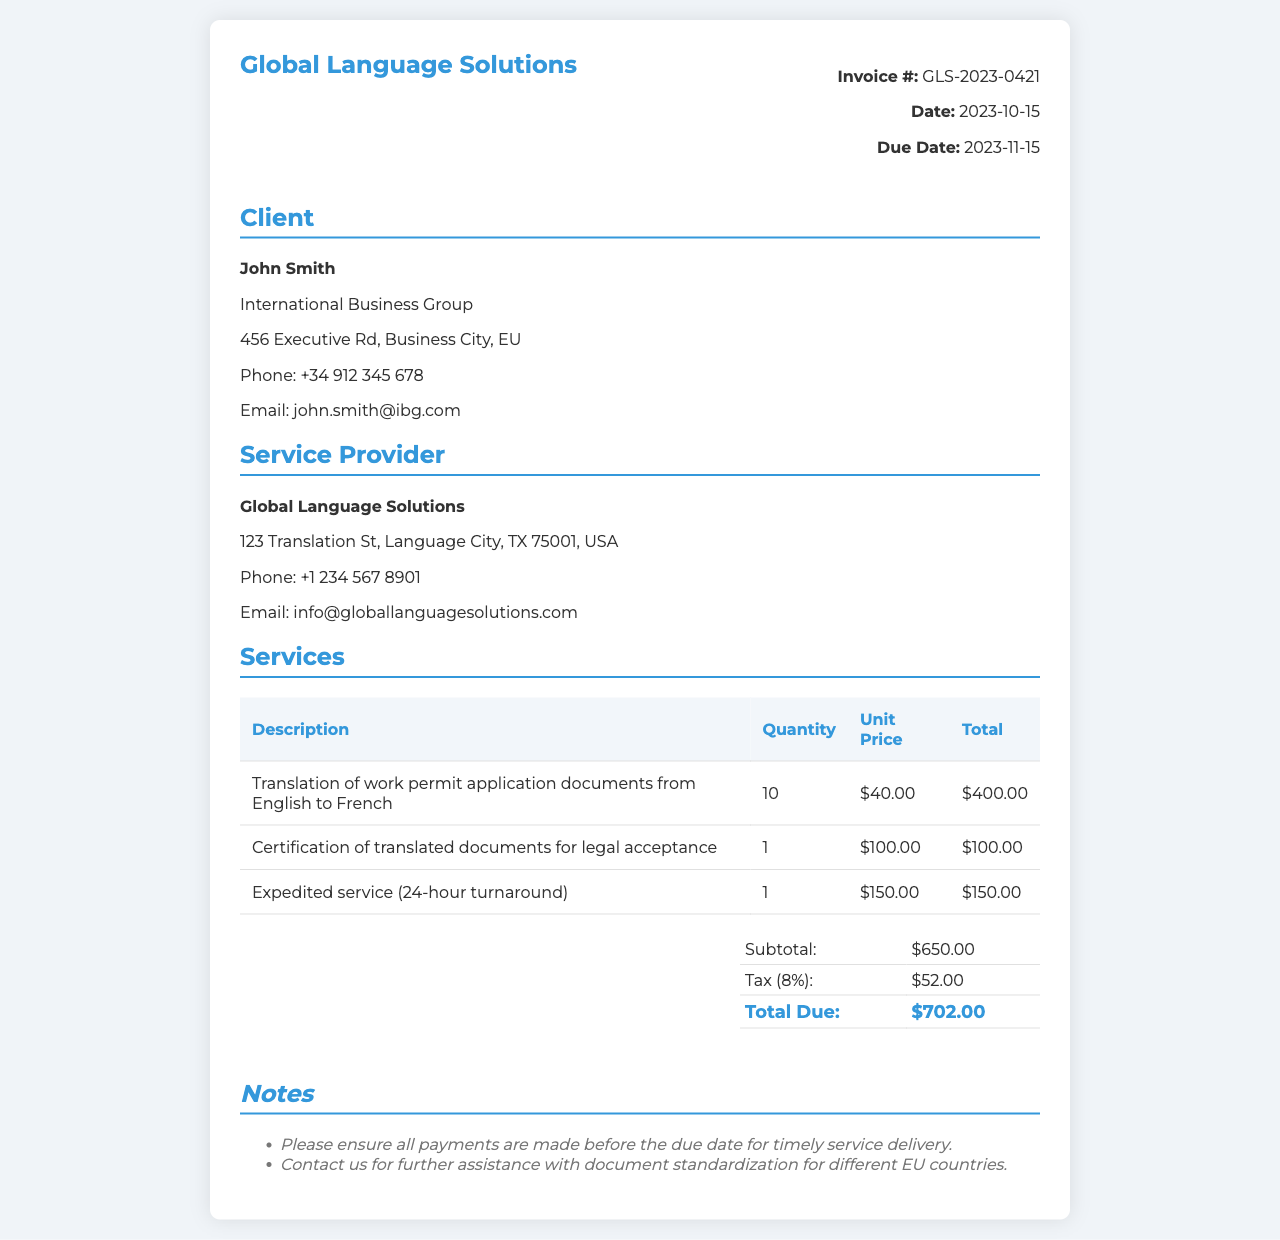What is the invoice number? The invoice number is specified in the document, which is important for tracking and reference purposes.
Answer: GLS-2023-0421 What is the date of the invoice? The date of the invoice indicates when the services were rendered and when payment is due.
Answer: 2023-10-15 Who is the client? The client section provides the name of the individual or organization receiving the services for identification.
Answer: John Smith What is the total due amount? The total due amount reflects the overall cost including services provided and applicable taxes.
Answer: $702.00 How many documents were translated? This refers to the quantity of work permit application documents that were translated, which impacts billing.
Answer: 10 What is the cost of certification? The cost associated with certifying the translated documents for legal acceptance is highlighted in the invoice.
Answer: $100.00 What percentage is the tax applied? The document specifies the tax rate applied to the services for calculating the total due.
Answer: 8% What is the service provider's email? This contact detail is crucial for clients to reach out for queries or further assistance.
Answer: info@globallanguagesolutions.com What service was expedited? This identifies the particular service that was offered with a quicker turnaround time, indicating urgency in the delivery.
Answer: Expedited service (24-hour turnaround) 